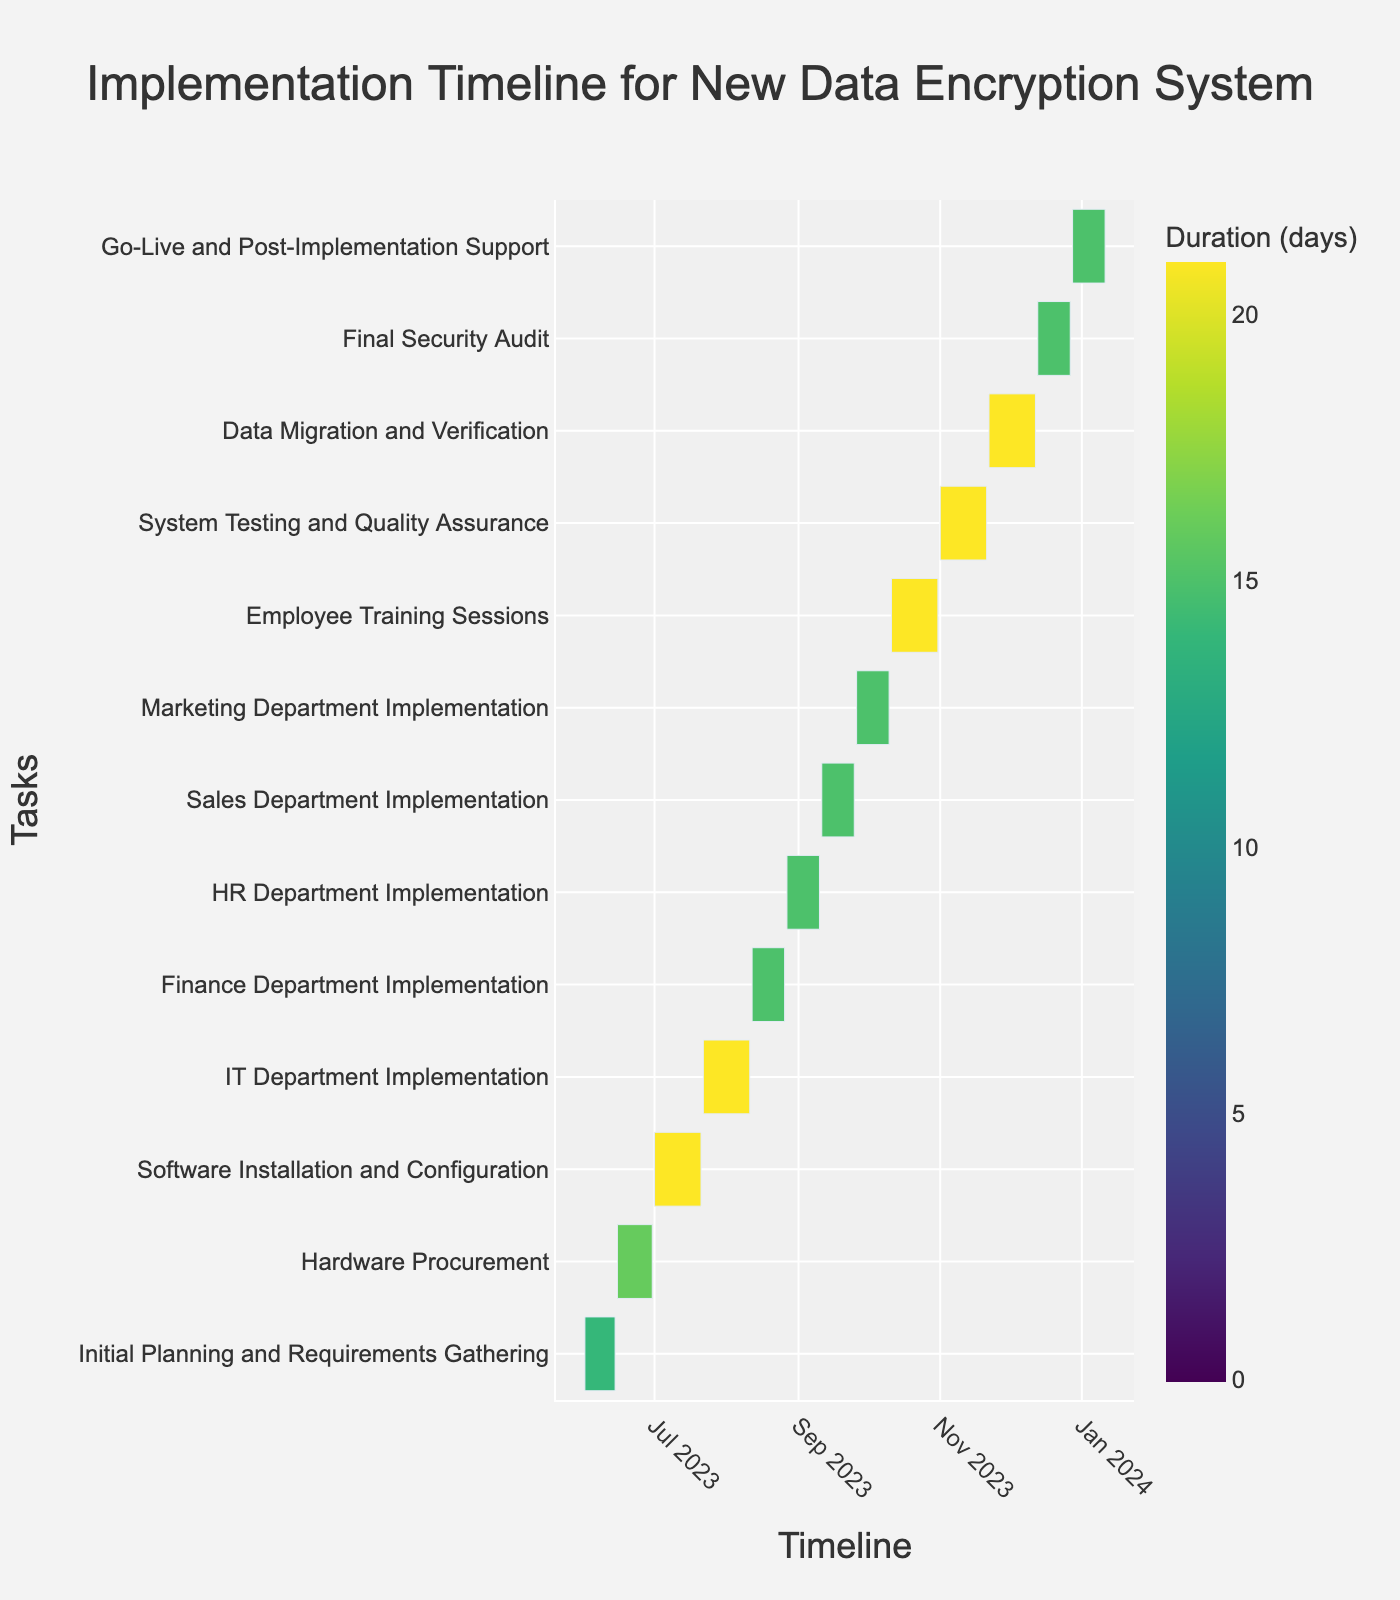What's the title of the Gantt chart? The title is typically displayed clearly on the top of the chart, which denotes the overall subject of the visualization. Refer to the center text at the top of the figure.
Answer: Implementation Timeline for New Data Encryption System What is the duration of the Hardware Procurement task? You can determine the duration by either observing the length of the bar associated with the task or referring to the legend that indicates duration directly on the chart.
Answer: 16 days Which task takes the longest to complete? Look for the bar that spans the greatest distance along the x-axis or find the task with the largest number of days in the legend.
Answer: Software Installation and Configuration How many tasks are scheduled to end in August? Examine the x-axis to identify tasks whose bars terminate in the month of August. Count these tasks.
Answer: Four tasks When does the Go-Live and Post-Implementation Support task begin and end? Identify the respective bar on the chart, and then read the corresponding start and end dates that are aligned with the x-axis.
Answer: 2023-12-28 to 2024-01-11 Which two tasks have the same duration and what is it? Compare the lengths of different bars or refer directly to the duration information. Identify tasks that share the same number of days in the legend.
Answer: Finance Department Implementation and HR Department Implementation; 15 days What is the total duration of the Initial Planning and Requirements Gathering and Employee Training Sessions tasks combined? Locate both tasks on the chart, note their durations, and sum them up. Initial Planning and Requirements Gathering is 14 days, and Employee Training Sessions is 21 days. 14 + 21 = 35 days
Answer: 35 days Which department's implementation is scheduled to take place last? Scan the y-axis for the task descriptions related to the departments and identify the latest one in the sequence stretching towards the right-most part of the chart.
Answer: Marketing Department Implementation How many days are allocated to System Testing and Quality Assurance? Find the corresponding bar on the chart or the duration noted in the legend.
Answer: 21 days Which task directly follows the HR Department Implementation? Follow the sequence of tasks along the y-axis and identify the task listed immediately after the HR Department Implementation.
Answer: Sales Department Implementation 